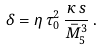Convert formula to latex. <formula><loc_0><loc_0><loc_500><loc_500>\delta = \eta \, \tau _ { 0 } ^ { 2 } \, \frac { \kappa \, s } { \bar { M } _ { 5 } ^ { 3 } } \, .</formula> 